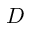<formula> <loc_0><loc_0><loc_500><loc_500>D</formula> 